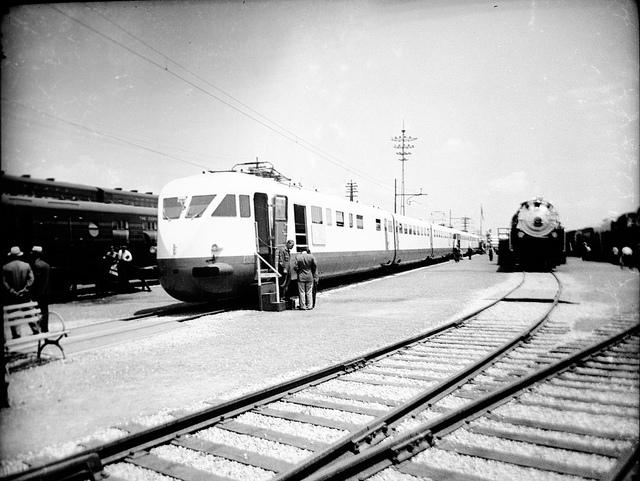What is there to sit on?
Give a very brief answer. Bench. Is a passenger getting off the train?
Short answer required. Yes. How many tracks are displayed?
Be succinct. 3. How many trains are on the track?
Answer briefly. 3. 